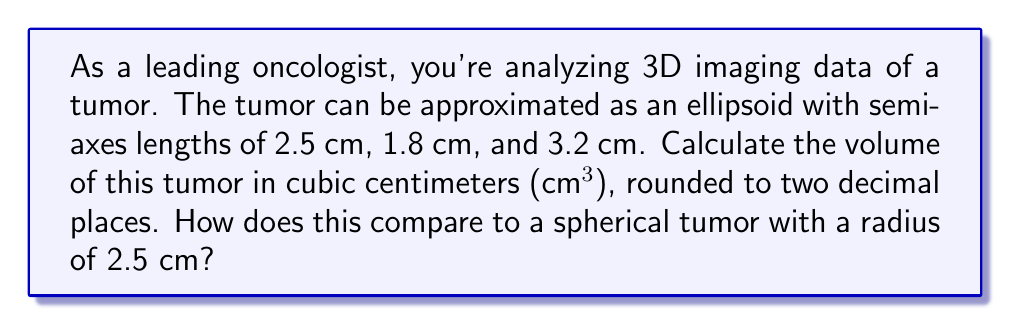Provide a solution to this math problem. To solve this problem, we'll follow these steps:

1. Calculate the volume of the ellipsoidal tumor
2. Calculate the volume of a spherical tumor with the given radius
3. Compare the two volumes

Step 1: Volume of the ellipsoidal tumor

The formula for the volume of an ellipsoid is:

$$V_e = \frac{4}{3}\pi abc$$

Where $a$, $b$, and $c$ are the lengths of the semi-axes.

Substituting the given values:

$$V_e = \frac{4}{3}\pi(2.5)(1.8)(3.2)$$

$$V_e = \frac{4}{3}\pi(14.4)$$

$$V_e = 19.2\pi$$

$$V_e \approx 60.32 \text{ cm}^3$$

Step 2: Volume of the spherical tumor

The formula for the volume of a sphere is:

$$V_s = \frac{4}{3}\pi r^3$$

Where $r$ is the radius of the sphere.

Substituting $r = 2.5$ cm:

$$V_s = \frac{4}{3}\pi(2.5)^3$$

$$V_s = \frac{4}{3}\pi(15.625)$$

$$V_s = 20.83\pi$$

$$V_s \approx 65.45 \text{ cm}^3$$

Step 3: Comparison

The ellipsoidal tumor has a volume of approximately 60.32 cm³, while the spherical tumor has a volume of approximately 65.45 cm³. The ellipsoidal tumor is about 7.8% smaller than the spherical tumor with the same maximum radius.

This comparison demonstrates how the shape of a tumor can significantly affect its volume, even when the maximum dimension is the same. This information is crucial for accurately assessing tumor size and growth in oncology research and treatment planning.
Answer: The volume of the ellipsoidal tumor is approximately 60.32 cm³. This is about 7.8% smaller than a spherical tumor with a radius of 2.5 cm, which would have a volume of approximately 65.45 cm³. 